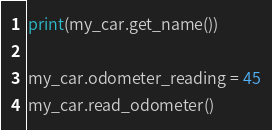<code> <loc_0><loc_0><loc_500><loc_500><_Python_>print(my_car.get_name())

my_car.odometer_reading = 45
my_car.read_odometer()</code> 